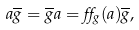Convert formula to latex. <formula><loc_0><loc_0><loc_500><loc_500>a \overline { g } = \overline { g } a = \alpha _ { g } ( a ) \overline { g } ,</formula> 